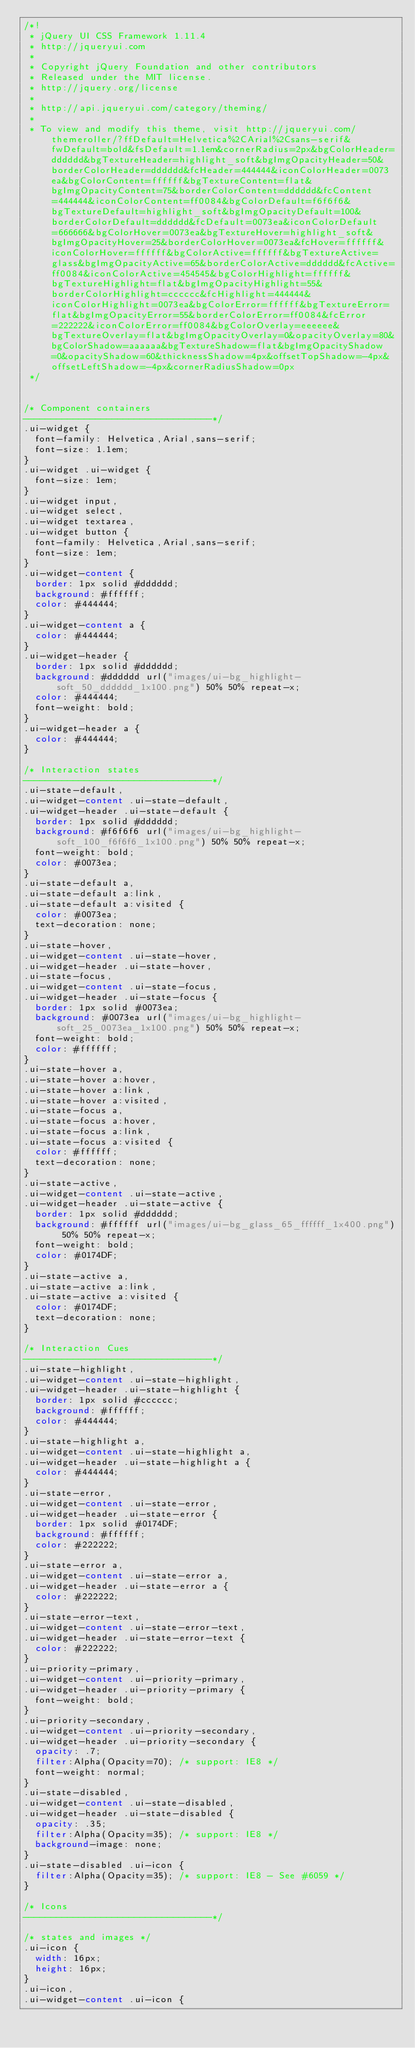Convert code to text. <code><loc_0><loc_0><loc_500><loc_500><_CSS_>/*!
 * jQuery UI CSS Framework 1.11.4
 * http://jqueryui.com
 *
 * Copyright jQuery Foundation and other contributors
 * Released under the MIT license.
 * http://jquery.org/license
 *
 * http://api.jqueryui.com/category/theming/
 *
 * To view and modify this theme, visit http://jqueryui.com/themeroller/?ffDefault=Helvetica%2CArial%2Csans-serif&fwDefault=bold&fsDefault=1.1em&cornerRadius=2px&bgColorHeader=dddddd&bgTextureHeader=highlight_soft&bgImgOpacityHeader=50&borderColorHeader=dddddd&fcHeader=444444&iconColorHeader=0073ea&bgColorContent=ffffff&bgTextureContent=flat&bgImgOpacityContent=75&borderColorContent=dddddd&fcContent=444444&iconColorContent=ff0084&bgColorDefault=f6f6f6&bgTextureDefault=highlight_soft&bgImgOpacityDefault=100&borderColorDefault=dddddd&fcDefault=0073ea&iconColorDefault=666666&bgColorHover=0073ea&bgTextureHover=highlight_soft&bgImgOpacityHover=25&borderColorHover=0073ea&fcHover=ffffff&iconColorHover=ffffff&bgColorActive=ffffff&bgTextureActive=glass&bgImgOpacityActive=65&borderColorActive=dddddd&fcActive=ff0084&iconColorActive=454545&bgColorHighlight=ffffff&bgTextureHighlight=flat&bgImgOpacityHighlight=55&borderColorHighlight=cccccc&fcHighlight=444444&iconColorHighlight=0073ea&bgColorError=ffffff&bgTextureError=flat&bgImgOpacityError=55&borderColorError=ff0084&fcError=222222&iconColorError=ff0084&bgColorOverlay=eeeeee&bgTextureOverlay=flat&bgImgOpacityOverlay=0&opacityOverlay=80&bgColorShadow=aaaaaa&bgTextureShadow=flat&bgImgOpacityShadow=0&opacityShadow=60&thicknessShadow=4px&offsetTopShadow=-4px&offsetLeftShadow=-4px&cornerRadiusShadow=0px
 */


/* Component containers
----------------------------------*/
.ui-widget {
	font-family: Helvetica,Arial,sans-serif;
	font-size: 1.1em;
}
.ui-widget .ui-widget {
	font-size: 1em;
}
.ui-widget input,
.ui-widget select,
.ui-widget textarea,
.ui-widget button {
	font-family: Helvetica,Arial,sans-serif;
	font-size: 1em;
}
.ui-widget-content {
	border: 1px solid #dddddd;
	background: #ffffff;
	color: #444444;
}
.ui-widget-content a {
	color: #444444;
}
.ui-widget-header {
	border: 1px solid #dddddd;
	background: #dddddd url("images/ui-bg_highlight-soft_50_dddddd_1x100.png") 50% 50% repeat-x;
	color: #444444;
	font-weight: bold;
}
.ui-widget-header a {
	color: #444444;
}

/* Interaction states
----------------------------------*/
.ui-state-default,
.ui-widget-content .ui-state-default,
.ui-widget-header .ui-state-default {
	border: 1px solid #dddddd;
	background: #f6f6f6 url("images/ui-bg_highlight-soft_100_f6f6f6_1x100.png") 50% 50% repeat-x;
	font-weight: bold;
	color: #0073ea;
}
.ui-state-default a,
.ui-state-default a:link,
.ui-state-default a:visited {
	color: #0073ea;
	text-decoration: none;
}
.ui-state-hover,
.ui-widget-content .ui-state-hover,
.ui-widget-header .ui-state-hover,
.ui-state-focus,
.ui-widget-content .ui-state-focus,
.ui-widget-header .ui-state-focus {
	border: 1px solid #0073ea;
	background: #0073ea url("images/ui-bg_highlight-soft_25_0073ea_1x100.png") 50% 50% repeat-x;
	font-weight: bold;
	color: #ffffff;
}
.ui-state-hover a,
.ui-state-hover a:hover,
.ui-state-hover a:link,
.ui-state-hover a:visited,
.ui-state-focus a,
.ui-state-focus a:hover,
.ui-state-focus a:link,
.ui-state-focus a:visited {
	color: #ffffff;
	text-decoration: none;
}
.ui-state-active,
.ui-widget-content .ui-state-active,
.ui-widget-header .ui-state-active {
	border: 1px solid #dddddd;
	background: #ffffff url("images/ui-bg_glass_65_ffffff_1x400.png") 50% 50% repeat-x;
	font-weight: bold;
	color: #0174DF;
}
.ui-state-active a,
.ui-state-active a:link,
.ui-state-active a:visited {
	color: #0174DF;
	text-decoration: none;
}

/* Interaction Cues
----------------------------------*/
.ui-state-highlight,
.ui-widget-content .ui-state-highlight,
.ui-widget-header .ui-state-highlight {
	border: 1px solid #cccccc;
	background: #ffffff;
	color: #444444;
}
.ui-state-highlight a,
.ui-widget-content .ui-state-highlight a,
.ui-widget-header .ui-state-highlight a {
	color: #444444;
}
.ui-state-error,
.ui-widget-content .ui-state-error,
.ui-widget-header .ui-state-error {
	border: 1px solid #0174DF;
	background: #ffffff;
	color: #222222;
}
.ui-state-error a,
.ui-widget-content .ui-state-error a,
.ui-widget-header .ui-state-error a {
	color: #222222;
}
.ui-state-error-text,
.ui-widget-content .ui-state-error-text,
.ui-widget-header .ui-state-error-text {
	color: #222222;
}
.ui-priority-primary,
.ui-widget-content .ui-priority-primary,
.ui-widget-header .ui-priority-primary {
	font-weight: bold;
}
.ui-priority-secondary,
.ui-widget-content .ui-priority-secondary,
.ui-widget-header .ui-priority-secondary {
	opacity: .7;
	filter:Alpha(Opacity=70); /* support: IE8 */
	font-weight: normal;
}
.ui-state-disabled,
.ui-widget-content .ui-state-disabled,
.ui-widget-header .ui-state-disabled {
	opacity: .35;
	filter:Alpha(Opacity=35); /* support: IE8 */
	background-image: none;
}
.ui-state-disabled .ui-icon {
	filter:Alpha(Opacity=35); /* support: IE8 - See #6059 */
}

/* Icons
----------------------------------*/

/* states and images */
.ui-icon {
	width: 16px;
	height: 16px;
}
.ui-icon,
.ui-widget-content .ui-icon {</code> 